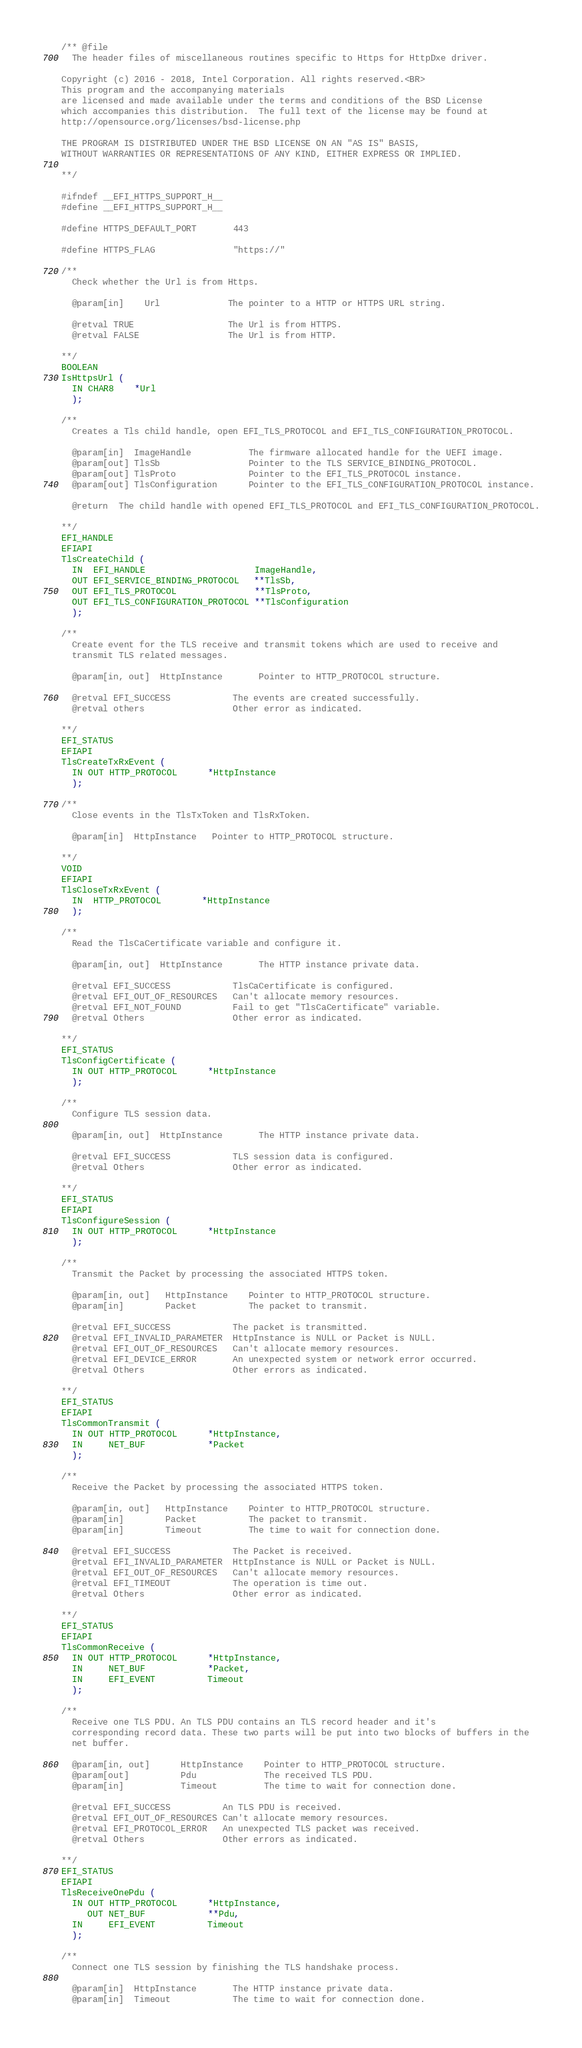<code> <loc_0><loc_0><loc_500><loc_500><_C_>/** @file
  The header files of miscellaneous routines specific to Https for HttpDxe driver.

Copyright (c) 2016 - 2018, Intel Corporation. All rights reserved.<BR>
This program and the accompanying materials
are licensed and made available under the terms and conditions of the BSD License
which accompanies this distribution.  The full text of the license may be found at
http://opensource.org/licenses/bsd-license.php

THE PROGRAM IS DISTRIBUTED UNDER THE BSD LICENSE ON AN "AS IS" BASIS,
WITHOUT WARRANTIES OR REPRESENTATIONS OF ANY KIND, EITHER EXPRESS OR IMPLIED.

**/

#ifndef __EFI_HTTPS_SUPPORT_H__
#define __EFI_HTTPS_SUPPORT_H__

#define HTTPS_DEFAULT_PORT       443

#define HTTPS_FLAG               "https://"

/**
  Check whether the Url is from Https.

  @param[in]    Url             The pointer to a HTTP or HTTPS URL string.

  @retval TRUE                  The Url is from HTTPS.
  @retval FALSE                 The Url is from HTTP.

**/
BOOLEAN
IsHttpsUrl (
  IN CHAR8    *Url
  );

/**
  Creates a Tls child handle, open EFI_TLS_PROTOCOL and EFI_TLS_CONFIGURATION_PROTOCOL.

  @param[in]  ImageHandle           The firmware allocated handle for the UEFI image.
  @param[out] TlsSb                 Pointer to the TLS SERVICE_BINDING_PROTOCOL.
  @param[out] TlsProto              Pointer to the EFI_TLS_PROTOCOL instance.
  @param[out] TlsConfiguration      Pointer to the EFI_TLS_CONFIGURATION_PROTOCOL instance.

  @return  The child handle with opened EFI_TLS_PROTOCOL and EFI_TLS_CONFIGURATION_PROTOCOL.

**/
EFI_HANDLE
EFIAPI
TlsCreateChild (
  IN  EFI_HANDLE                     ImageHandle,
  OUT EFI_SERVICE_BINDING_PROTOCOL   **TlsSb,
  OUT EFI_TLS_PROTOCOL               **TlsProto,
  OUT EFI_TLS_CONFIGURATION_PROTOCOL **TlsConfiguration
  );

/**
  Create event for the TLS receive and transmit tokens which are used to receive and
  transmit TLS related messages.

  @param[in, out]  HttpInstance       Pointer to HTTP_PROTOCOL structure.

  @retval EFI_SUCCESS            The events are created successfully.
  @retval others                 Other error as indicated.

**/
EFI_STATUS
EFIAPI
TlsCreateTxRxEvent (
  IN OUT HTTP_PROTOCOL      *HttpInstance
  );

/**
  Close events in the TlsTxToken and TlsRxToken.

  @param[in]  HttpInstance   Pointer to HTTP_PROTOCOL structure.

**/
VOID
EFIAPI
TlsCloseTxRxEvent (
  IN  HTTP_PROTOCOL        *HttpInstance
  );

/**
  Read the TlsCaCertificate variable and configure it.

  @param[in, out]  HttpInstance       The HTTP instance private data.

  @retval EFI_SUCCESS            TlsCaCertificate is configured.
  @retval EFI_OUT_OF_RESOURCES   Can't allocate memory resources.
  @retval EFI_NOT_FOUND          Fail to get "TlsCaCertificate" variable.
  @retval Others                 Other error as indicated.

**/
EFI_STATUS
TlsConfigCertificate (
  IN OUT HTTP_PROTOCOL      *HttpInstance
  );

/**
  Configure TLS session data.

  @param[in, out]  HttpInstance       The HTTP instance private data.

  @retval EFI_SUCCESS            TLS session data is configured.
  @retval Others                 Other error as indicated.

**/
EFI_STATUS
EFIAPI
TlsConfigureSession (
  IN OUT HTTP_PROTOCOL      *HttpInstance
  );

/**
  Transmit the Packet by processing the associated HTTPS token.

  @param[in, out]   HttpInstance    Pointer to HTTP_PROTOCOL structure.
  @param[in]        Packet          The packet to transmit.

  @retval EFI_SUCCESS            The packet is transmitted.
  @retval EFI_INVALID_PARAMETER  HttpInstance is NULL or Packet is NULL.
  @retval EFI_OUT_OF_RESOURCES   Can't allocate memory resources.
  @retval EFI_DEVICE_ERROR       An unexpected system or network error occurred.
  @retval Others                 Other errors as indicated.

**/
EFI_STATUS
EFIAPI
TlsCommonTransmit (
  IN OUT HTTP_PROTOCOL      *HttpInstance,
  IN     NET_BUF            *Packet
  );

/**
  Receive the Packet by processing the associated HTTPS token.

  @param[in, out]   HttpInstance    Pointer to HTTP_PROTOCOL structure.
  @param[in]        Packet          The packet to transmit.
  @param[in]        Timeout         The time to wait for connection done.

  @retval EFI_SUCCESS            The Packet is received.
  @retval EFI_INVALID_PARAMETER  HttpInstance is NULL or Packet is NULL.
  @retval EFI_OUT_OF_RESOURCES   Can't allocate memory resources.
  @retval EFI_TIMEOUT            The operation is time out.
  @retval Others                 Other error as indicated.

**/
EFI_STATUS
EFIAPI
TlsCommonReceive (
  IN OUT HTTP_PROTOCOL      *HttpInstance,
  IN     NET_BUF            *Packet,
  IN     EFI_EVENT          Timeout
  );

/**
  Receive one TLS PDU. An TLS PDU contains an TLS record header and it's
  corresponding record data. These two parts will be put into two blocks of buffers in the
  net buffer.

  @param[in, out]      HttpInstance    Pointer to HTTP_PROTOCOL structure.
  @param[out]          Pdu             The received TLS PDU.
  @param[in]           Timeout         The time to wait for connection done.

  @retval EFI_SUCCESS          An TLS PDU is received.
  @retval EFI_OUT_OF_RESOURCES Can't allocate memory resources.
  @retval EFI_PROTOCOL_ERROR   An unexpected TLS packet was received.
  @retval Others               Other errors as indicated.

**/
EFI_STATUS
EFIAPI
TlsReceiveOnePdu (
  IN OUT HTTP_PROTOCOL      *HttpInstance,
     OUT NET_BUF            **Pdu,
  IN     EFI_EVENT          Timeout
  );

/**
  Connect one TLS session by finishing the TLS handshake process.

  @param[in]  HttpInstance       The HTTP instance private data.
  @param[in]  Timeout            The time to wait for connection done.
</code> 